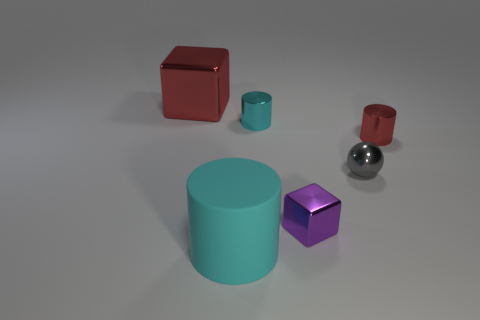Subtract all gray cylinders. Subtract all brown cubes. How many cylinders are left? 3 Add 4 tiny gray metal spheres. How many objects exist? 10 Subtract all cubes. How many objects are left? 4 Add 5 small cyan metal cylinders. How many small cyan metal cylinders are left? 6 Add 4 red metal things. How many red metal things exist? 6 Subtract 0 gray blocks. How many objects are left? 6 Subtract all tiny cyan cylinders. Subtract all small cyan metal things. How many objects are left? 4 